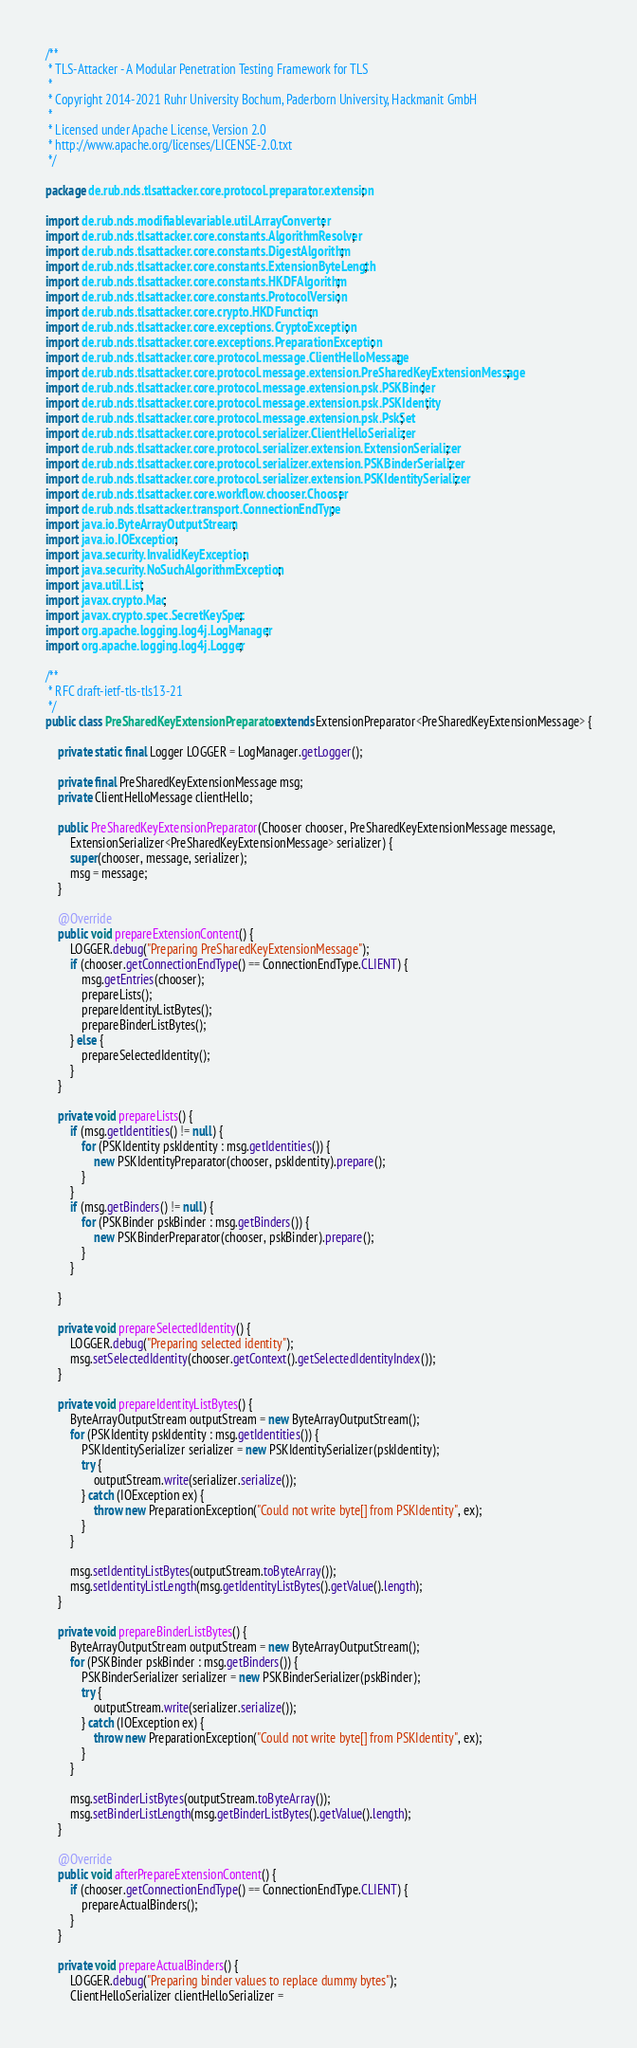Convert code to text. <code><loc_0><loc_0><loc_500><loc_500><_Java_>/**
 * TLS-Attacker - A Modular Penetration Testing Framework for TLS
 *
 * Copyright 2014-2021 Ruhr University Bochum, Paderborn University, Hackmanit GmbH
 *
 * Licensed under Apache License, Version 2.0
 * http://www.apache.org/licenses/LICENSE-2.0.txt
 */

package de.rub.nds.tlsattacker.core.protocol.preparator.extension;

import de.rub.nds.modifiablevariable.util.ArrayConverter;
import de.rub.nds.tlsattacker.core.constants.AlgorithmResolver;
import de.rub.nds.tlsattacker.core.constants.DigestAlgorithm;
import de.rub.nds.tlsattacker.core.constants.ExtensionByteLength;
import de.rub.nds.tlsattacker.core.constants.HKDFAlgorithm;
import de.rub.nds.tlsattacker.core.constants.ProtocolVersion;
import de.rub.nds.tlsattacker.core.crypto.HKDFunction;
import de.rub.nds.tlsattacker.core.exceptions.CryptoException;
import de.rub.nds.tlsattacker.core.exceptions.PreparationException;
import de.rub.nds.tlsattacker.core.protocol.message.ClientHelloMessage;
import de.rub.nds.tlsattacker.core.protocol.message.extension.PreSharedKeyExtensionMessage;
import de.rub.nds.tlsattacker.core.protocol.message.extension.psk.PSKBinder;
import de.rub.nds.tlsattacker.core.protocol.message.extension.psk.PSKIdentity;
import de.rub.nds.tlsattacker.core.protocol.message.extension.psk.PskSet;
import de.rub.nds.tlsattacker.core.protocol.serializer.ClientHelloSerializer;
import de.rub.nds.tlsattacker.core.protocol.serializer.extension.ExtensionSerializer;
import de.rub.nds.tlsattacker.core.protocol.serializer.extension.PSKBinderSerializer;
import de.rub.nds.tlsattacker.core.protocol.serializer.extension.PSKIdentitySerializer;
import de.rub.nds.tlsattacker.core.workflow.chooser.Chooser;
import de.rub.nds.tlsattacker.transport.ConnectionEndType;
import java.io.ByteArrayOutputStream;
import java.io.IOException;
import java.security.InvalidKeyException;
import java.security.NoSuchAlgorithmException;
import java.util.List;
import javax.crypto.Mac;
import javax.crypto.spec.SecretKeySpec;
import org.apache.logging.log4j.LogManager;
import org.apache.logging.log4j.Logger;

/**
 * RFC draft-ietf-tls-tls13-21
 */
public class PreSharedKeyExtensionPreparator extends ExtensionPreparator<PreSharedKeyExtensionMessage> {

    private static final Logger LOGGER = LogManager.getLogger();

    private final PreSharedKeyExtensionMessage msg;
    private ClientHelloMessage clientHello;

    public PreSharedKeyExtensionPreparator(Chooser chooser, PreSharedKeyExtensionMessage message,
        ExtensionSerializer<PreSharedKeyExtensionMessage> serializer) {
        super(chooser, message, serializer);
        msg = message;
    }

    @Override
    public void prepareExtensionContent() {
        LOGGER.debug("Preparing PreSharedKeyExtensionMessage");
        if (chooser.getConnectionEndType() == ConnectionEndType.CLIENT) {
            msg.getEntries(chooser);
            prepareLists();
            prepareIdentityListBytes();
            prepareBinderListBytes();
        } else {
            prepareSelectedIdentity();
        }
    }

    private void prepareLists() {
        if (msg.getIdentities() != null) {
            for (PSKIdentity pskIdentity : msg.getIdentities()) {
                new PSKIdentityPreparator(chooser, pskIdentity).prepare();
            }
        }
        if (msg.getBinders() != null) {
            for (PSKBinder pskBinder : msg.getBinders()) {
                new PSKBinderPreparator(chooser, pskBinder).prepare();
            }
        }

    }

    private void prepareSelectedIdentity() {
        LOGGER.debug("Preparing selected identity");
        msg.setSelectedIdentity(chooser.getContext().getSelectedIdentityIndex());
    }

    private void prepareIdentityListBytes() {
        ByteArrayOutputStream outputStream = new ByteArrayOutputStream();
        for (PSKIdentity pskIdentity : msg.getIdentities()) {
            PSKIdentitySerializer serializer = new PSKIdentitySerializer(pskIdentity);
            try {
                outputStream.write(serializer.serialize());
            } catch (IOException ex) {
                throw new PreparationException("Could not write byte[] from PSKIdentity", ex);
            }
        }

        msg.setIdentityListBytes(outputStream.toByteArray());
        msg.setIdentityListLength(msg.getIdentityListBytes().getValue().length);
    }

    private void prepareBinderListBytes() {
        ByteArrayOutputStream outputStream = new ByteArrayOutputStream();
        for (PSKBinder pskBinder : msg.getBinders()) {
            PSKBinderSerializer serializer = new PSKBinderSerializer(pskBinder);
            try {
                outputStream.write(serializer.serialize());
            } catch (IOException ex) {
                throw new PreparationException("Could not write byte[] from PSKIdentity", ex);
            }
        }

        msg.setBinderListBytes(outputStream.toByteArray());
        msg.setBinderListLength(msg.getBinderListBytes().getValue().length);
    }

    @Override
    public void afterPrepareExtensionContent() {
        if (chooser.getConnectionEndType() == ConnectionEndType.CLIENT) {
            prepareActualBinders();
        }
    }

    private void prepareActualBinders() {
        LOGGER.debug("Preparing binder values to replace dummy bytes");
        ClientHelloSerializer clientHelloSerializer =</code> 